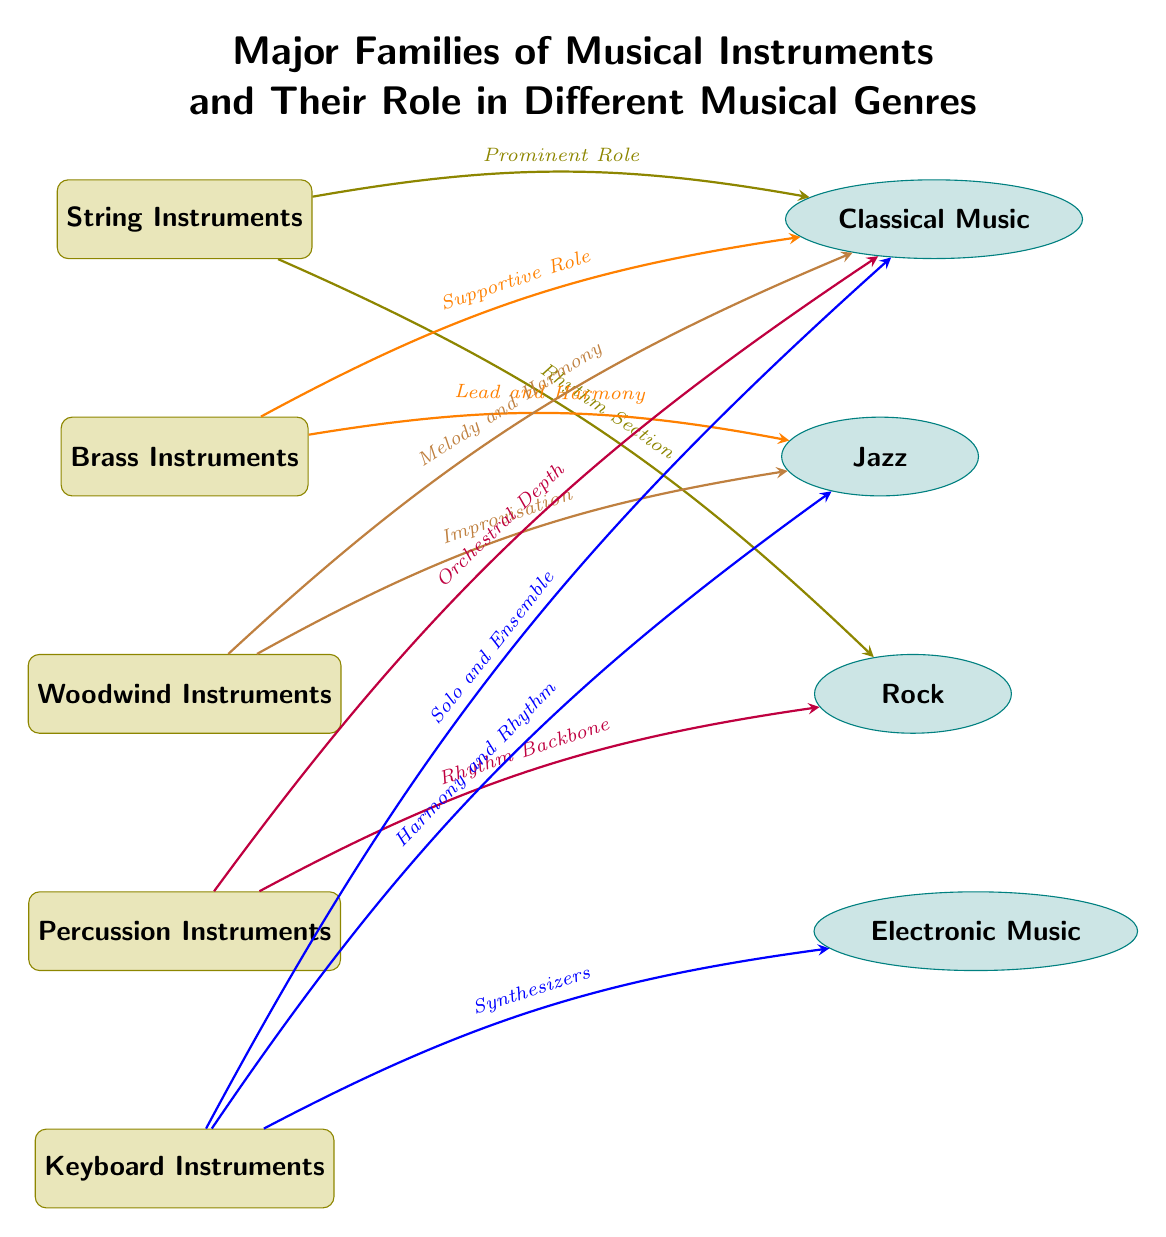What are the major families of musical instruments listed in the diagram? The diagram includes five major families of musical instruments: String Instruments, Brass Instruments, Woodwind Instruments, Percussion Instruments, and Keyboard Instruments. This information can be found in the instrument nodes of the diagram.
Answer: String Instruments, Brass Instruments, Woodwind Instruments, Percussion Instruments, Keyboard Instruments Which instrument family is primarily associated with rhythm in rock music? According to the diagram, Percussion Instruments are linked to the role of the rhythm backbone in rock music. This can be seen through the arrow connecting the percussion node to the rock genre node with the label "Rhythm Backbone."
Answer: Percussion Instruments How many musical genres are represented in the diagram? The diagram shows four musical genres: Classical Music, Jazz, Rock, and Electronic Music. Each genre node is distinct and connected to the respective instrument families through arrows, indicating their relationship.
Answer: 4 What is the relationship between Brass Instruments and Jazz music? The diagram depicts that Brass Instruments have a "Lead and Harmony" role in Jazz music, illustrated by the arrow pointing from the brass node to the jazz node with this specific label.
Answer: Lead and Harmony Which instrument family contributes to orchestral depth in Classical Music? The diagram indicates that Percussion Instruments are responsible for providing orchestral depth in Classical Music, as shown by the corresponding arrow from the percussion node to the classical node labeled "Orchestral Depth."
Answer: Percussion Instruments What role do String Instruments play in Classical Music? String Instruments have a "Prominent Role" in Classical Music, as indicated by the arrow that connects the string node to the classical music node with this description.
Answer: Prominent Role Which instrument family is linked to synthesizers in Electronic Music? The diagram signifies that Keyboard Instruments are connected to synthesizers in Electronic Music through an arrow that points from the keyboard node to the electronic node with the label "Synthesizers."
Answer: Keyboard Instruments How do Woodwind Instruments contribute to Jazz? According to the diagram, Woodwind Instruments facilitate "Improvisation" in Jazz music, shown by the arrow from the woodwind node to the jazz node with that label.
Answer: Improvisation 